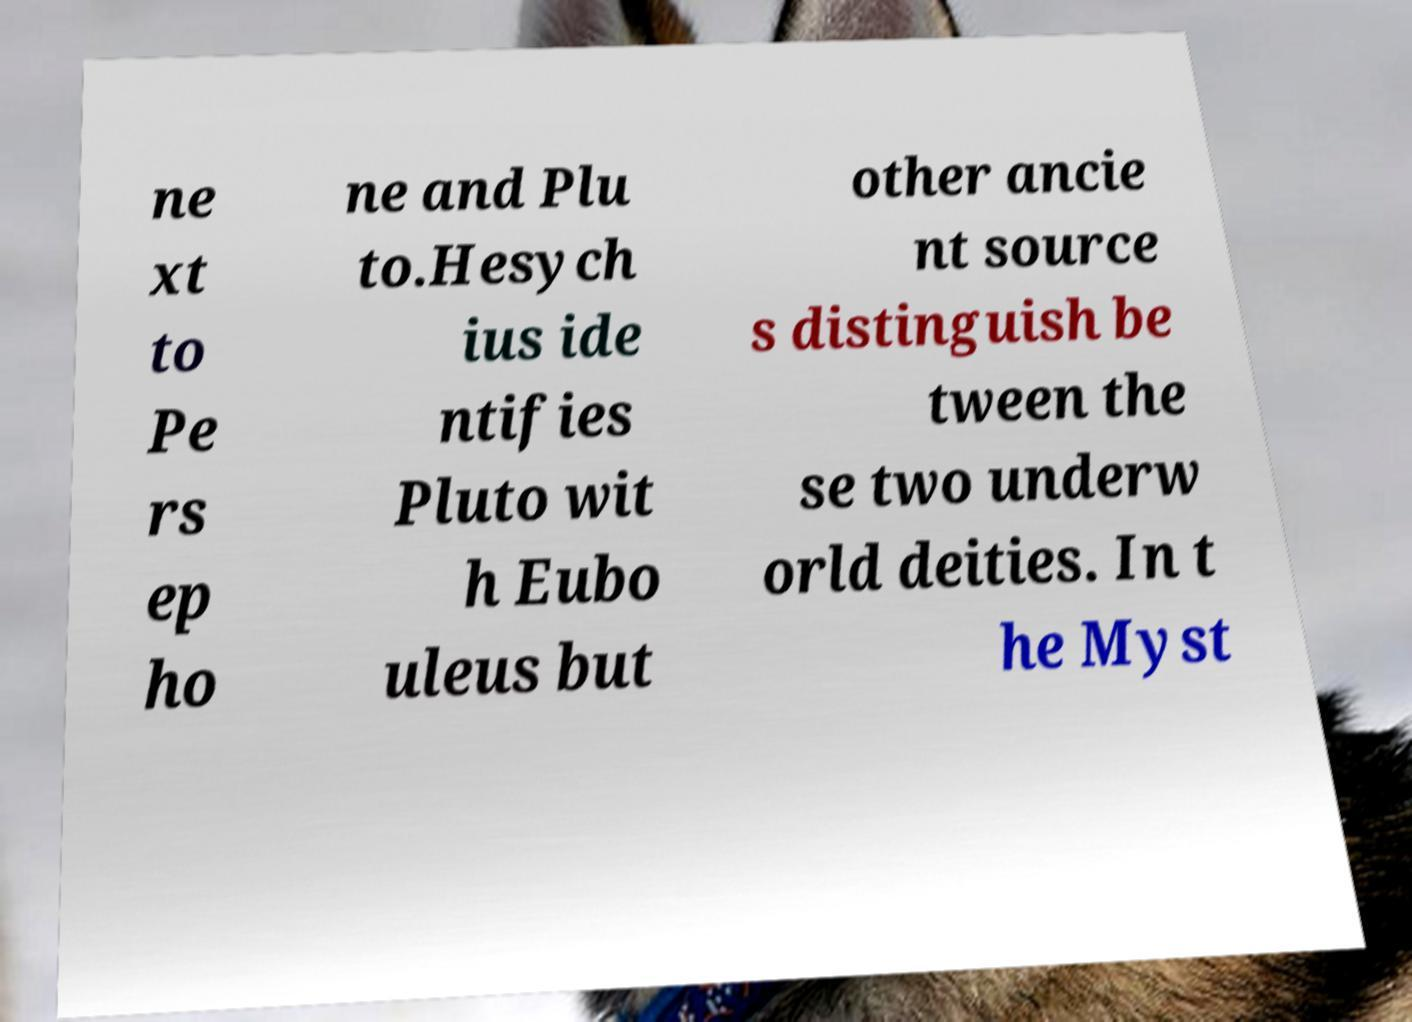Could you extract and type out the text from this image? ne xt to Pe rs ep ho ne and Plu to.Hesych ius ide ntifies Pluto wit h Eubo uleus but other ancie nt source s distinguish be tween the se two underw orld deities. In t he Myst 